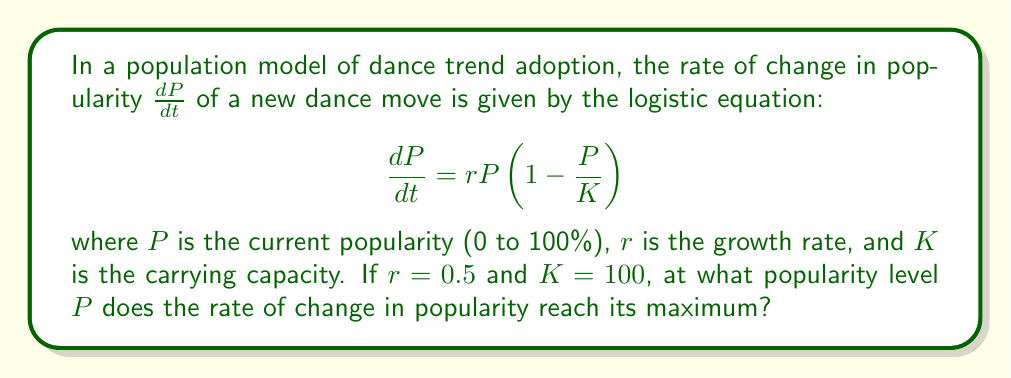Can you solve this math problem? To find the maximum rate of change, we need to find the inflection point of the logistic curve. This occurs at half the carrying capacity. Here's why:

1) The rate of change is given by:
   $$\frac{dP}{dt} = 0.5P(1-\frac{P}{100})$$

2) Expand this equation:
   $$\frac{dP}{dt} = 0.5P - 0.005P^2$$

3) To find the maximum, we need to differentiate this with respect to $P$ and set it to zero:
   $$\frac{d}{dP}(\frac{dP}{dt}) = 0.5 - 0.01P = 0$$

4) Solve for $P$:
   $$0.5 - 0.01P = 0$$
   $$0.01P = 0.5$$
   $$P = 50$$

5) This confirms that the maximum rate of change occurs at half the carrying capacity (K/2 = 100/2 = 50).

In the context of dance trends, this means the new dance move's popularity is spreading fastest when it has reached 50% adoption among the potential dancers.
Answer: 50% 